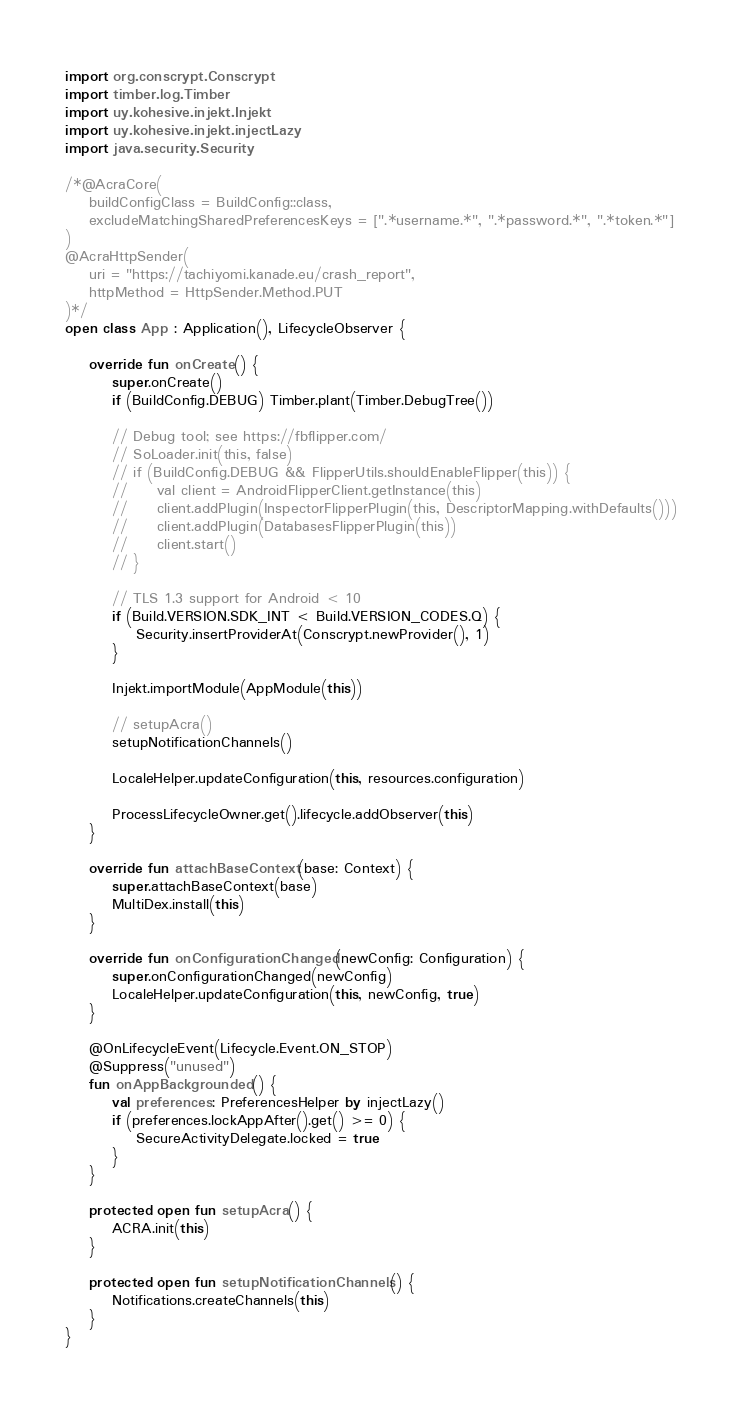<code> <loc_0><loc_0><loc_500><loc_500><_Kotlin_>import org.conscrypt.Conscrypt
import timber.log.Timber
import uy.kohesive.injekt.Injekt
import uy.kohesive.injekt.injectLazy
import java.security.Security

/*@AcraCore(
    buildConfigClass = BuildConfig::class,
    excludeMatchingSharedPreferencesKeys = [".*username.*", ".*password.*", ".*token.*"]
)
@AcraHttpSender(
    uri = "https://tachiyomi.kanade.eu/crash_report",
    httpMethod = HttpSender.Method.PUT
)*/
open class App : Application(), LifecycleObserver {

    override fun onCreate() {
        super.onCreate()
        if (BuildConfig.DEBUG) Timber.plant(Timber.DebugTree())

        // Debug tool; see https://fbflipper.com/
        // SoLoader.init(this, false)
        // if (BuildConfig.DEBUG && FlipperUtils.shouldEnableFlipper(this)) {
        //     val client = AndroidFlipperClient.getInstance(this)
        //     client.addPlugin(InspectorFlipperPlugin(this, DescriptorMapping.withDefaults()))
        //     client.addPlugin(DatabasesFlipperPlugin(this))
        //     client.start()
        // }

        // TLS 1.3 support for Android < 10
        if (Build.VERSION.SDK_INT < Build.VERSION_CODES.Q) {
            Security.insertProviderAt(Conscrypt.newProvider(), 1)
        }

        Injekt.importModule(AppModule(this))

        // setupAcra()
        setupNotificationChannels()

        LocaleHelper.updateConfiguration(this, resources.configuration)

        ProcessLifecycleOwner.get().lifecycle.addObserver(this)
    }

    override fun attachBaseContext(base: Context) {
        super.attachBaseContext(base)
        MultiDex.install(this)
    }

    override fun onConfigurationChanged(newConfig: Configuration) {
        super.onConfigurationChanged(newConfig)
        LocaleHelper.updateConfiguration(this, newConfig, true)
    }

    @OnLifecycleEvent(Lifecycle.Event.ON_STOP)
    @Suppress("unused")
    fun onAppBackgrounded() {
        val preferences: PreferencesHelper by injectLazy()
        if (preferences.lockAppAfter().get() >= 0) {
            SecureActivityDelegate.locked = true
        }
    }

    protected open fun setupAcra() {
        ACRA.init(this)
    }

    protected open fun setupNotificationChannels() {
        Notifications.createChannels(this)
    }
}
</code> 